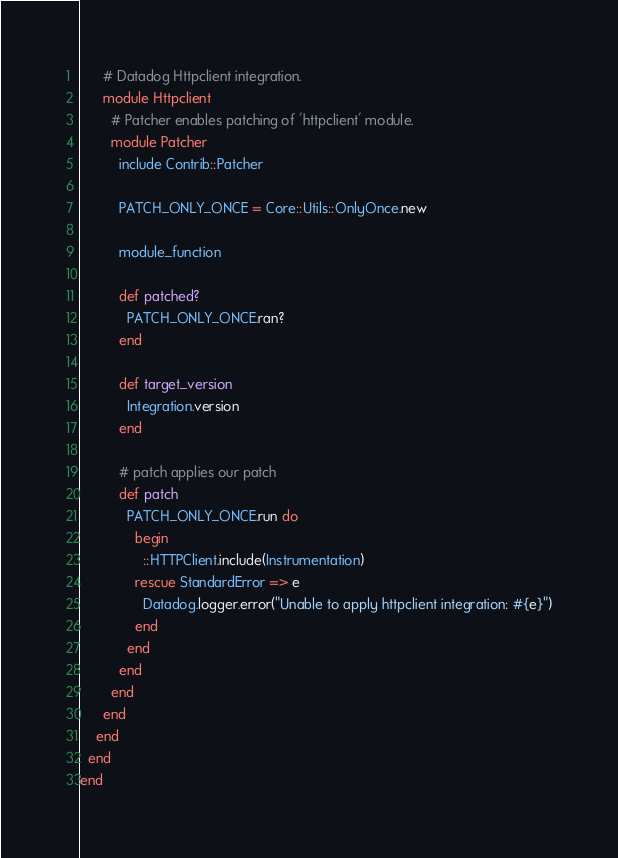<code> <loc_0><loc_0><loc_500><loc_500><_Ruby_>      # Datadog Httpclient integration.
      module Httpclient
        # Patcher enables patching of 'httpclient' module.
        module Patcher
          include Contrib::Patcher

          PATCH_ONLY_ONCE = Core::Utils::OnlyOnce.new

          module_function

          def patched?
            PATCH_ONLY_ONCE.ran?
          end

          def target_version
            Integration.version
          end

          # patch applies our patch
          def patch
            PATCH_ONLY_ONCE.run do
              begin
                ::HTTPClient.include(Instrumentation)
              rescue StandardError => e
                Datadog.logger.error("Unable to apply httpclient integration: #{e}")
              end
            end
          end
        end
      end
    end
  end
end
</code> 